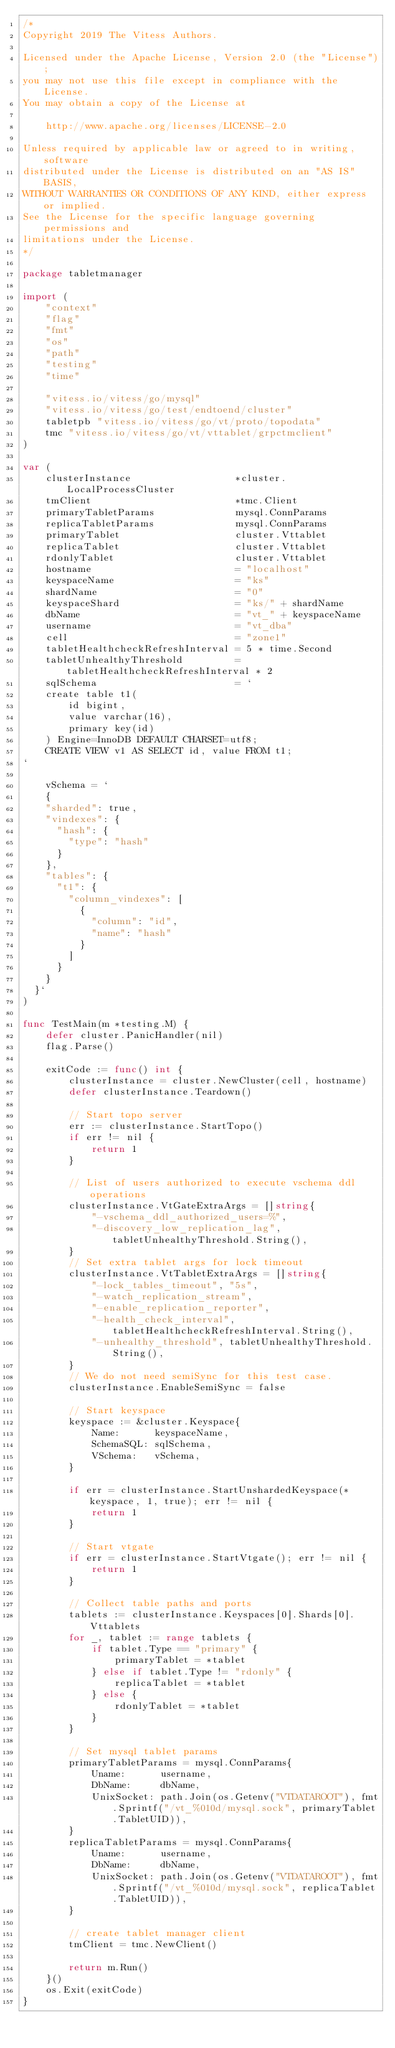Convert code to text. <code><loc_0><loc_0><loc_500><loc_500><_Go_>/*
Copyright 2019 The Vitess Authors.

Licensed under the Apache License, Version 2.0 (the "License");
you may not use this file except in compliance with the License.
You may obtain a copy of the License at

    http://www.apache.org/licenses/LICENSE-2.0

Unless required by applicable law or agreed to in writing, software
distributed under the License is distributed on an "AS IS" BASIS,
WITHOUT WARRANTIES OR CONDITIONS OF ANY KIND, either express or implied.
See the License for the specific language governing permissions and
limitations under the License.
*/

package tabletmanager

import (
	"context"
	"flag"
	"fmt"
	"os"
	"path"
	"testing"
	"time"

	"vitess.io/vitess/go/mysql"
	"vitess.io/vitess/go/test/endtoend/cluster"
	tabletpb "vitess.io/vitess/go/vt/proto/topodata"
	tmc "vitess.io/vitess/go/vt/vttablet/grpctmclient"
)

var (
	clusterInstance                  *cluster.LocalProcessCluster
	tmClient                         *tmc.Client
	primaryTabletParams              mysql.ConnParams
	replicaTabletParams              mysql.ConnParams
	primaryTablet                    cluster.Vttablet
	replicaTablet                    cluster.Vttablet
	rdonlyTablet                     cluster.Vttablet
	hostname                         = "localhost"
	keyspaceName                     = "ks"
	shardName                        = "0"
	keyspaceShard                    = "ks/" + shardName
	dbName                           = "vt_" + keyspaceName
	username                         = "vt_dba"
	cell                             = "zone1"
	tabletHealthcheckRefreshInterval = 5 * time.Second
	tabletUnhealthyThreshold         = tabletHealthcheckRefreshInterval * 2
	sqlSchema                        = `
	create table t1(
		id bigint,
		value varchar(16),
		primary key(id)
	) Engine=InnoDB DEFAULT CHARSET=utf8;
	CREATE VIEW v1 AS SELECT id, value FROM t1;
`

	vSchema = `
	{
    "sharded": true,
    "vindexes": {
      "hash": {
        "type": "hash"
      }
    },
    "tables": {
      "t1": {
        "column_vindexes": [
          {
            "column": "id",
            "name": "hash"
          }
        ]
      }
    }
  }`
)

func TestMain(m *testing.M) {
	defer cluster.PanicHandler(nil)
	flag.Parse()

	exitCode := func() int {
		clusterInstance = cluster.NewCluster(cell, hostname)
		defer clusterInstance.Teardown()

		// Start topo server
		err := clusterInstance.StartTopo()
		if err != nil {
			return 1
		}

		// List of users authorized to execute vschema ddl operations
		clusterInstance.VtGateExtraArgs = []string{
			"-vschema_ddl_authorized_users=%",
			"-discovery_low_replication_lag", tabletUnhealthyThreshold.String(),
		}
		// Set extra tablet args for lock timeout
		clusterInstance.VtTabletExtraArgs = []string{
			"-lock_tables_timeout", "5s",
			"-watch_replication_stream",
			"-enable_replication_reporter",
			"-health_check_interval", tabletHealthcheckRefreshInterval.String(),
			"-unhealthy_threshold", tabletUnhealthyThreshold.String(),
		}
		// We do not need semiSync for this test case.
		clusterInstance.EnableSemiSync = false

		// Start keyspace
		keyspace := &cluster.Keyspace{
			Name:      keyspaceName,
			SchemaSQL: sqlSchema,
			VSchema:   vSchema,
		}

		if err = clusterInstance.StartUnshardedKeyspace(*keyspace, 1, true); err != nil {
			return 1
		}

		// Start vtgate
		if err = clusterInstance.StartVtgate(); err != nil {
			return 1
		}

		// Collect table paths and ports
		tablets := clusterInstance.Keyspaces[0].Shards[0].Vttablets
		for _, tablet := range tablets {
			if tablet.Type == "primary" {
				primaryTablet = *tablet
			} else if tablet.Type != "rdonly" {
				replicaTablet = *tablet
			} else {
				rdonlyTablet = *tablet
			}
		}

		// Set mysql tablet params
		primaryTabletParams = mysql.ConnParams{
			Uname:      username,
			DbName:     dbName,
			UnixSocket: path.Join(os.Getenv("VTDATAROOT"), fmt.Sprintf("/vt_%010d/mysql.sock", primaryTablet.TabletUID)),
		}
		replicaTabletParams = mysql.ConnParams{
			Uname:      username,
			DbName:     dbName,
			UnixSocket: path.Join(os.Getenv("VTDATAROOT"), fmt.Sprintf("/vt_%010d/mysql.sock", replicaTablet.TabletUID)),
		}

		// create tablet manager client
		tmClient = tmc.NewClient()

		return m.Run()
	}()
	os.Exit(exitCode)
}
</code> 